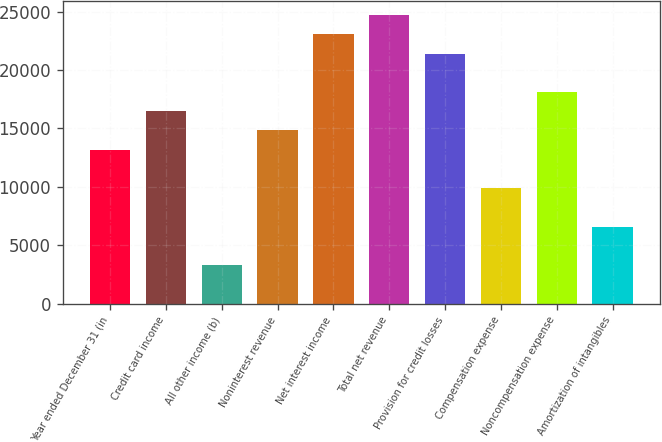Convert chart. <chart><loc_0><loc_0><loc_500><loc_500><bar_chart><fcel>Year ended December 31 (in<fcel>Credit card income<fcel>All other income (b)<fcel>Noninterest revenue<fcel>Net interest income<fcel>Total net revenue<fcel>Provision for credit losses<fcel>Compensation expense<fcel>Noncompensation expense<fcel>Amortization of intangibles<nl><fcel>13180.2<fcel>16474<fcel>3298.8<fcel>14827.1<fcel>23061.6<fcel>24708.5<fcel>21414.7<fcel>9886.4<fcel>18120.9<fcel>6592.6<nl></chart> 